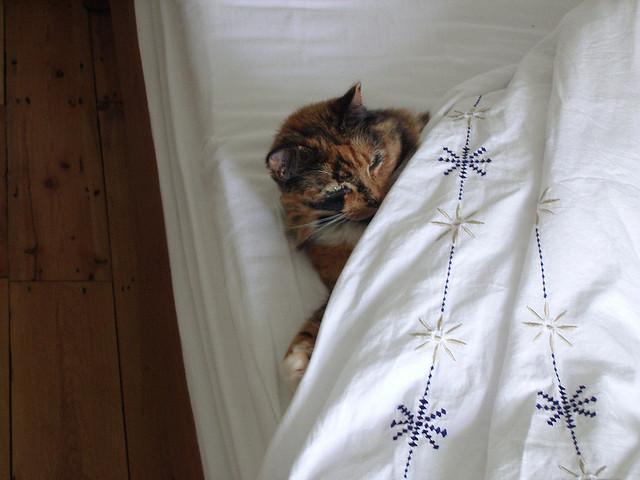What color is the cat?
Give a very brief answer. Brown and black. What type of flooring is in this room?
Write a very short answer. Wood. Is the pattern more winter or summer colors?
Keep it brief. Winter. 